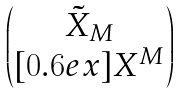<formula> <loc_0><loc_0><loc_500><loc_500>\begin{pmatrix} \, \tilde { X } _ { M } \, \\ [ 0 . 6 e x ] { X ^ { M } } \end{pmatrix}</formula> 